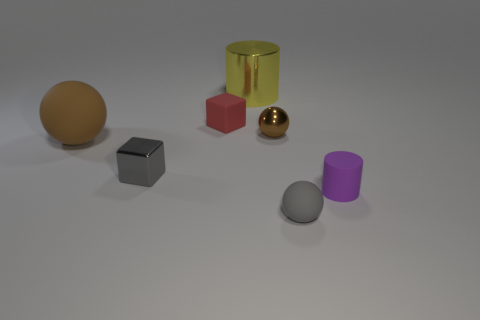Add 3 shiny objects. How many objects exist? 10 Subtract 0 green balls. How many objects are left? 7 Subtract all balls. How many objects are left? 4 Subtract all small gray spheres. Subtract all red rubber cubes. How many objects are left? 5 Add 6 large brown matte balls. How many large brown matte balls are left? 7 Add 3 tiny gray things. How many tiny gray things exist? 5 